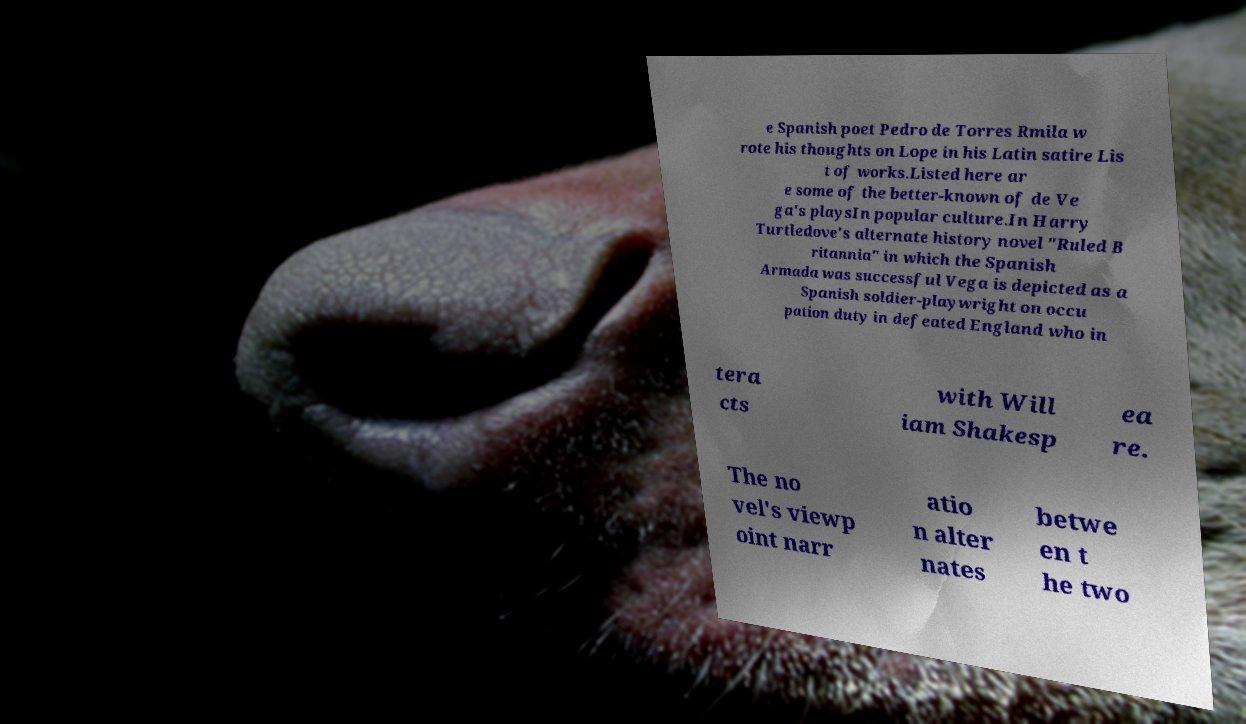Please identify and transcribe the text found in this image. e Spanish poet Pedro de Torres Rmila w rote his thoughts on Lope in his Latin satire Lis t of works.Listed here ar e some of the better-known of de Ve ga's playsIn popular culture.In Harry Turtledove's alternate history novel "Ruled B ritannia" in which the Spanish Armada was successful Vega is depicted as a Spanish soldier-playwright on occu pation duty in defeated England who in tera cts with Will iam Shakesp ea re. The no vel's viewp oint narr atio n alter nates betwe en t he two 